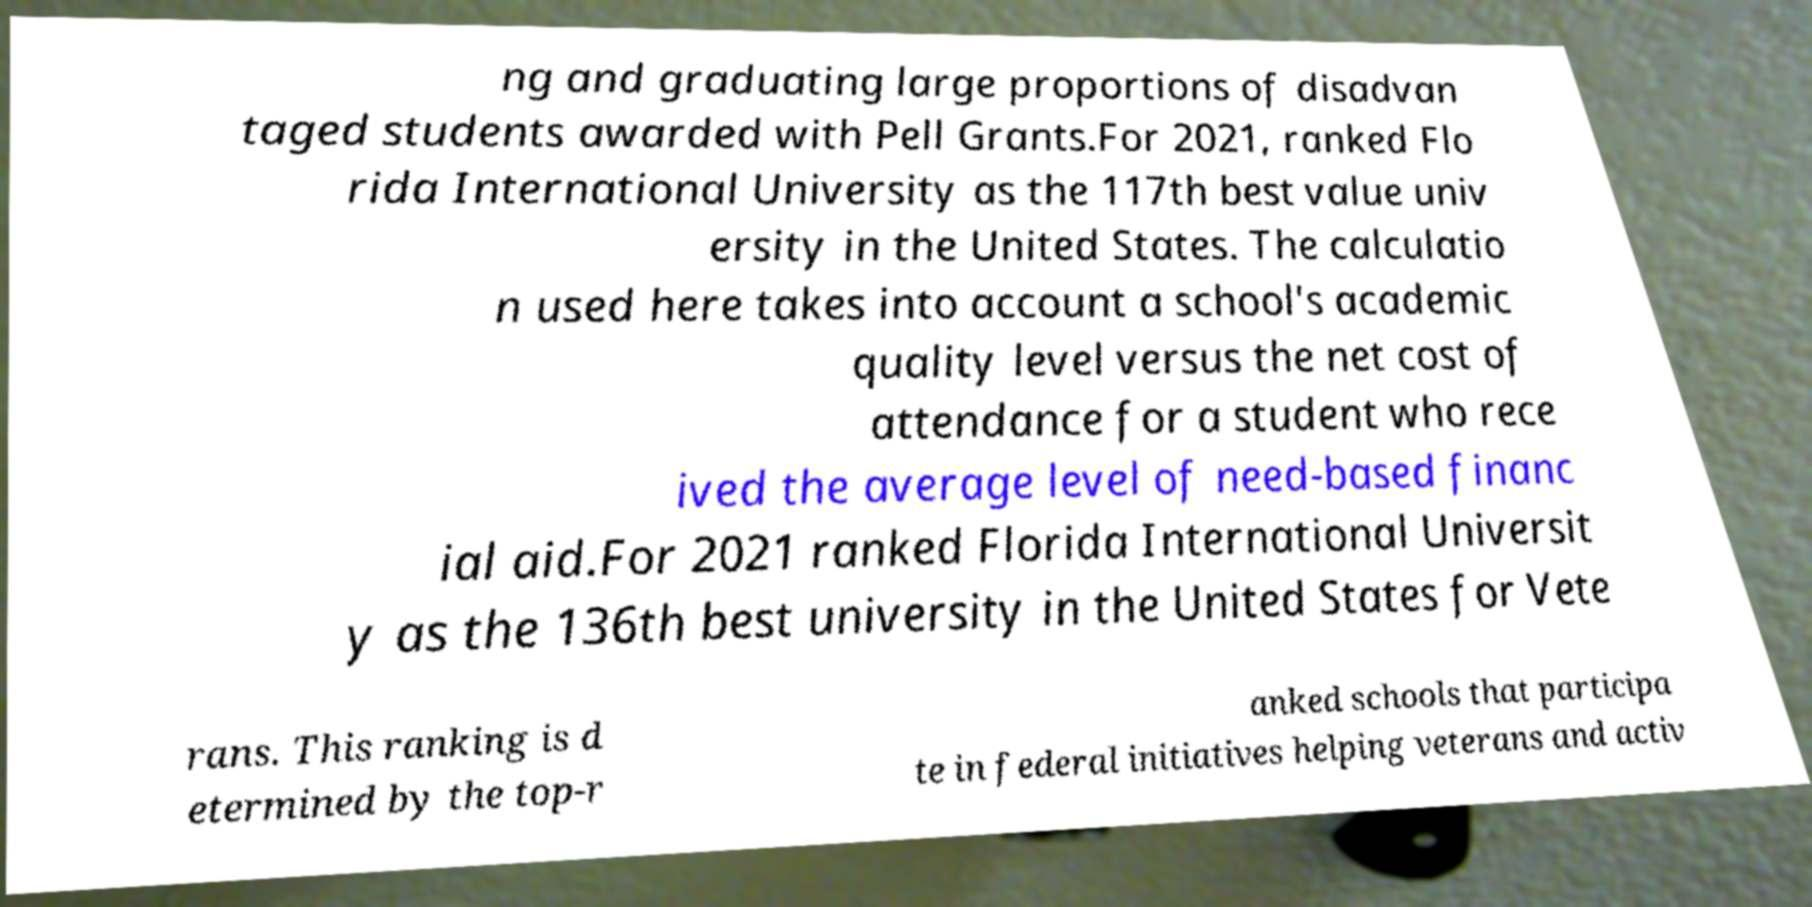Please read and relay the text visible in this image. What does it say? ng and graduating large proportions of disadvan taged students awarded with Pell Grants.For 2021, ranked Flo rida International University as the 117th best value univ ersity in the United States. The calculatio n used here takes into account a school's academic quality level versus the net cost of attendance for a student who rece ived the average level of need-based financ ial aid.For 2021 ranked Florida International Universit y as the 136th best university in the United States for Vete rans. This ranking is d etermined by the top-r anked schools that participa te in federal initiatives helping veterans and activ 